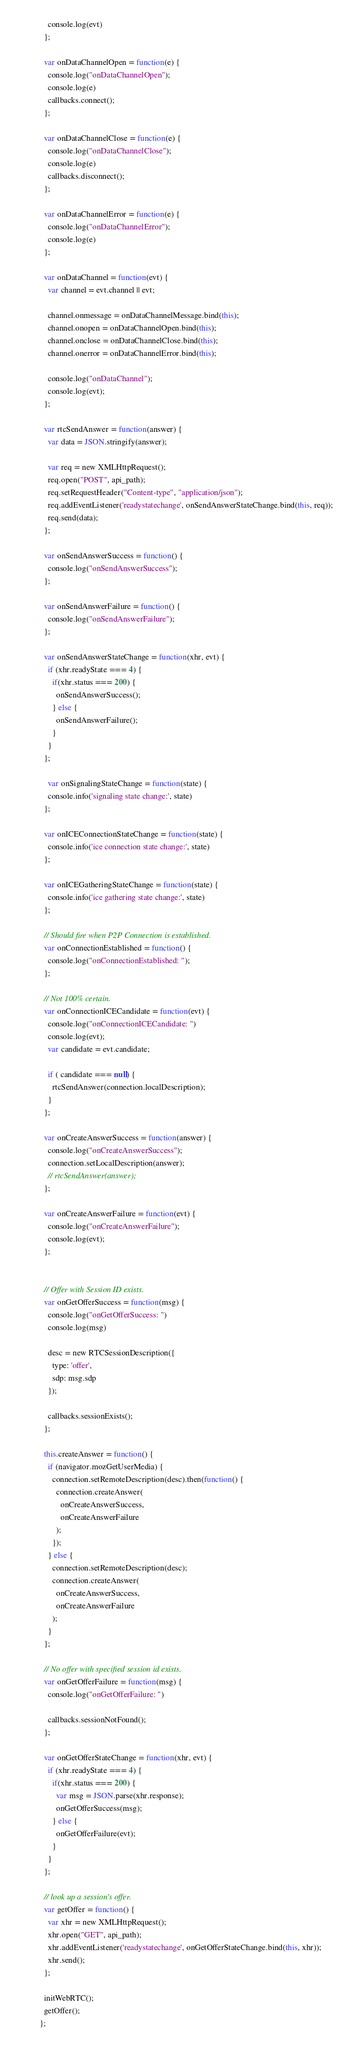Convert code to text. <code><loc_0><loc_0><loc_500><loc_500><_JavaScript_>    console.log(evt)
  };

  var onDataChannelOpen = function(e) {
    console.log("onDataChannelOpen");
    console.log(e)
    callbacks.connect();
  };

  var onDataChannelClose = function(e) {
    console.log("onDataChannelClose");
    console.log(e)
    callbacks.disconnect();
  };

  var onDataChannelError = function(e) {
    console.log("onDataChannelError");
    console.log(e)
  };

  var onDataChannel = function(evt) {
    var channel = evt.channel || evt;

    channel.onmessage = onDataChannelMessage.bind(this);
    channel.onopen = onDataChannelOpen.bind(this);
    channel.onclose = onDataChannelClose.bind(this);
    channel.onerror = onDataChannelError.bind(this);

    console.log("onDataChannel");
    console.log(evt);
  };

  var rtcSendAnswer = function(answer) {
    var data = JSON.stringify(answer);

    var req = new XMLHttpRequest();
    req.open("POST", api_path);
    req.setRequestHeader("Content-type", "application/json");
    req.addEventListener('readystatechange', onSendAnswerStateChange.bind(this, req));
    req.send(data);
  };

  var onSendAnswerSuccess = function() {
    console.log("onSendAnswerSuccess");
  };

  var onSendAnswerFailure = function() {
    console.log("onSendAnswerFailure");
  };

  var onSendAnswerStateChange = function(xhr, evt) {
    if (xhr.readyState === 4) {
      if(xhr.status === 200) {
        onSendAnswerSuccess();
      } else {
        onSendAnswerFailure();
      }
    }
  };

	var onSignalingStateChange = function(state) {
    console.info('signaling state change:', state)
  };

  var onICEConnectionStateChange = function(state) {
    console.info('ice connection state change:', state)
  };

  var onICEGatheringStateChange = function(state) {
    console.info('ice gathering state change:', state)
  };

  // Should fire when P2P Connection is established.
  var onConnectionEstablished = function() {
    console.log("onConnectionEstablished: ");
  };

  // Not 100% certain.
  var onConnectionICECandidate = function(evt) {
    console.log("onConnectionICECandidate: ")
    console.log(evt);
    var candidate = evt.candidate;

    if ( candidate === null) {
      rtcSendAnswer(connection.localDescription);
    }
  };

  var onCreateAnswerSuccess = function(answer) {
    console.log("onCreateAnswerSuccess");
    connection.setLocalDescription(answer);
    // rtcSendAnswer(answer);
  };

  var onCreateAnswerFailure = function(evt) {
    console.log("onCreateAnswerFailure");
    console.log(evt);
  };


  // Offer with Session ID exists.
  var onGetOfferSuccess = function(msg) {
    console.log("onGetOfferSuccess: ")
    console.log(msg)

    desc = new RTCSessionDescription({
      type: 'offer',
      sdp: msg.sdp
    });

    callbacks.sessionExists();
  };

  this.createAnswer = function() {
    if (navigator.mozGetUserMedia) {
      connection.setRemoteDescription(desc).then(function() {
        connection.createAnswer(
          onCreateAnswerSuccess,
          onCreateAnswerFailure
        );
      });
    } else {
      connection.setRemoteDescription(desc);
      connection.createAnswer(
        onCreateAnswerSuccess,
        onCreateAnswerFailure
      );
    }
  };

  // No offer with specified session id exists.
  var onGetOfferFailure = function(msg) {
    console.log("onGetOfferFailure: ")

    callbacks.sessionNotFound();
  };

  var onGetOfferStateChange = function(xhr, evt) {
    if (xhr.readyState === 4) {
      if(xhr.status === 200) {
        var msg = JSON.parse(xhr.response);
        onGetOfferSuccess(msg);
      } else {
        onGetOfferFailure(evt);
      }
    }
  };

  // look up a session's offer.
  var getOffer = function() {
    var xhr = new XMLHttpRequest();
    xhr.open("GET", api_path);
    xhr.addEventListener('readystatechange', onGetOfferStateChange.bind(this, xhr));
    xhr.send();
  };

  initWebRTC();
  getOffer();
};
</code> 